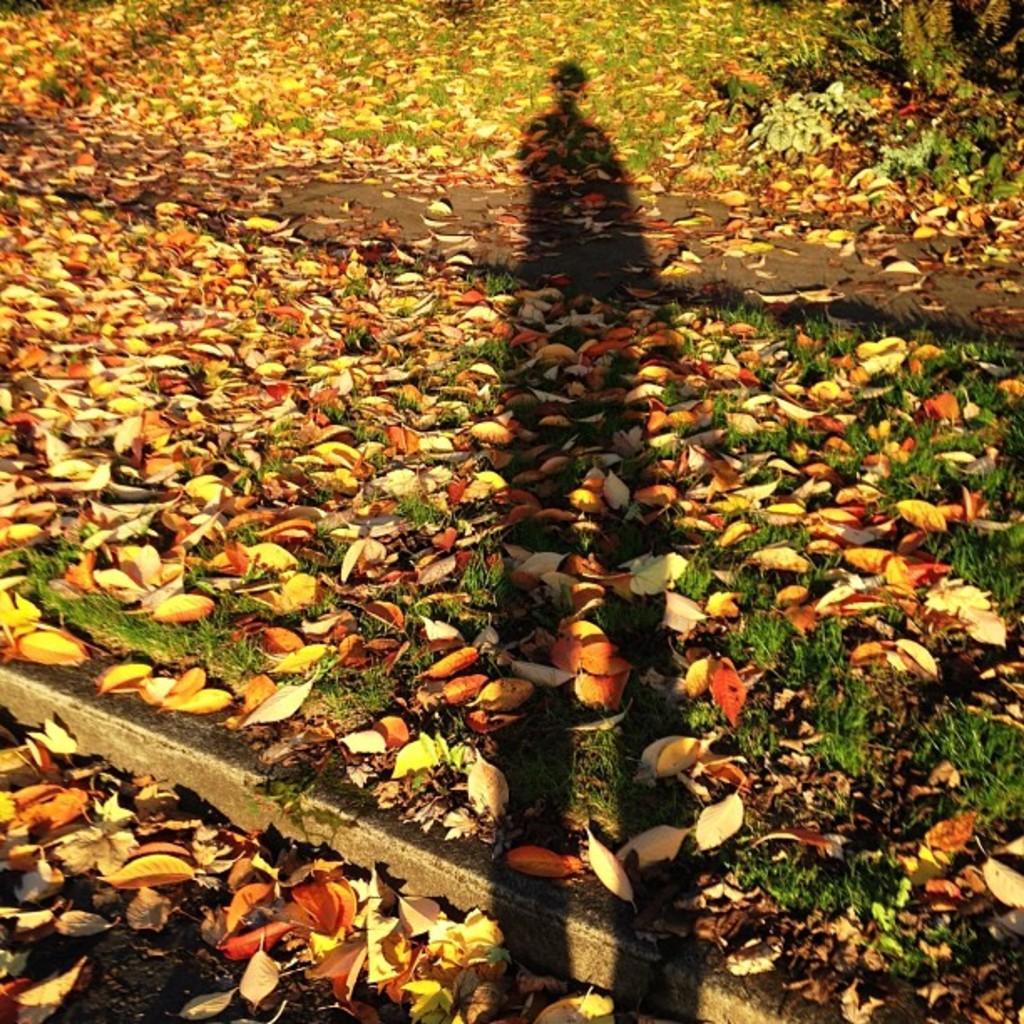Can you describe this image briefly? In this image, we can see some dried leaves and there is a shadow of the person on the ground. 